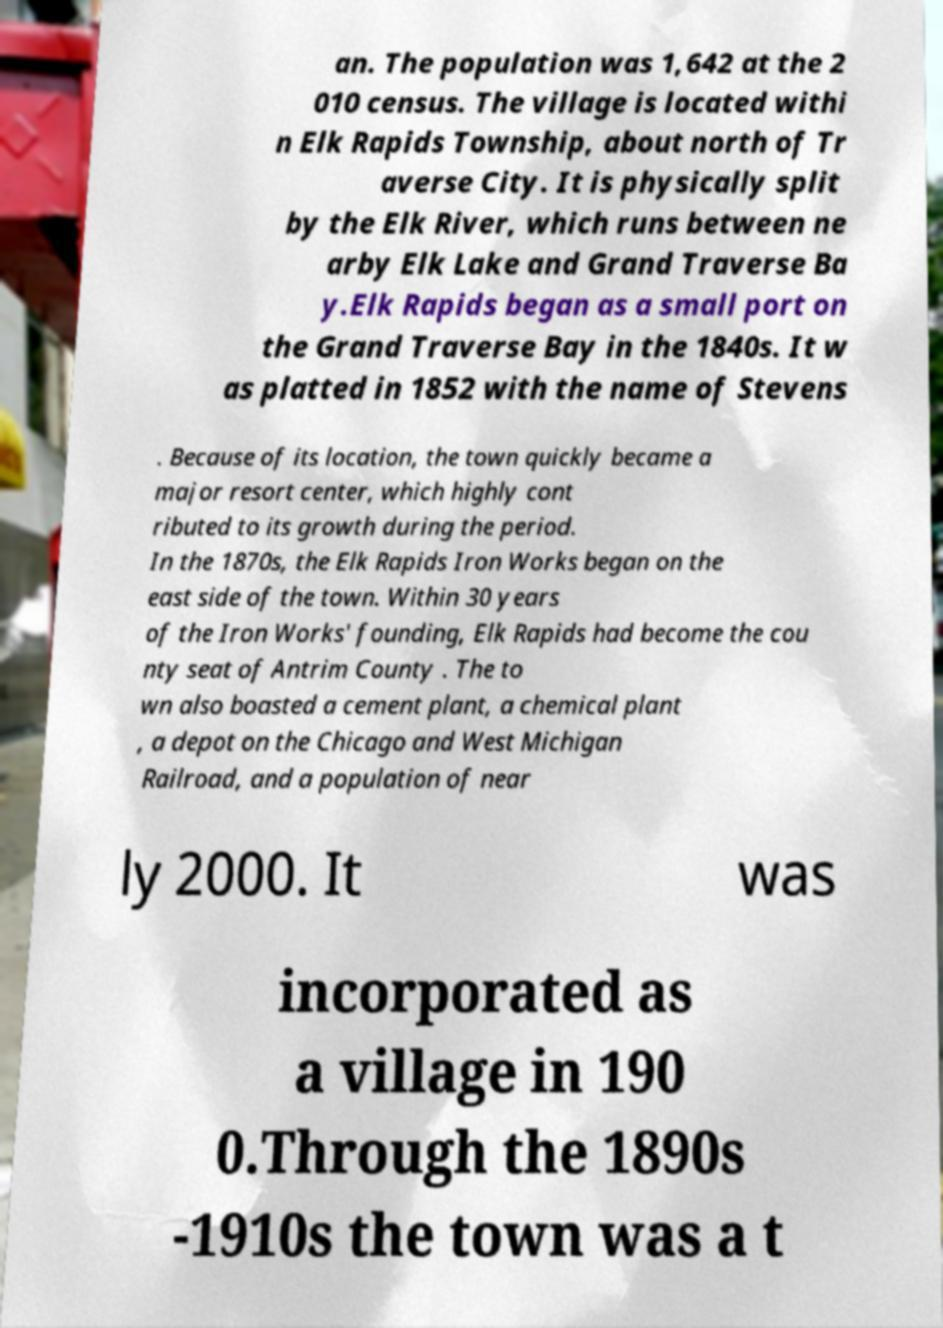Can you accurately transcribe the text from the provided image for me? an. The population was 1,642 at the 2 010 census. The village is located withi n Elk Rapids Township, about north of Tr averse City. It is physically split by the Elk River, which runs between ne arby Elk Lake and Grand Traverse Ba y.Elk Rapids began as a small port on the Grand Traverse Bay in the 1840s. It w as platted in 1852 with the name of Stevens . Because of its location, the town quickly became a major resort center, which highly cont ributed to its growth during the period. In the 1870s, the Elk Rapids Iron Works began on the east side of the town. Within 30 years of the Iron Works' founding, Elk Rapids had become the cou nty seat of Antrim County . The to wn also boasted a cement plant, a chemical plant , a depot on the Chicago and West Michigan Railroad, and a population of near ly 2000. It was incorporated as a village in 190 0.Through the 1890s -1910s the town was a t 